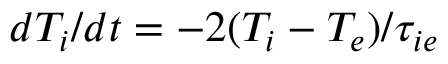<formula> <loc_0><loc_0><loc_500><loc_500>d T _ { i } / d t = - 2 ( T _ { i } - T _ { e } ) / \tau _ { i e }</formula> 